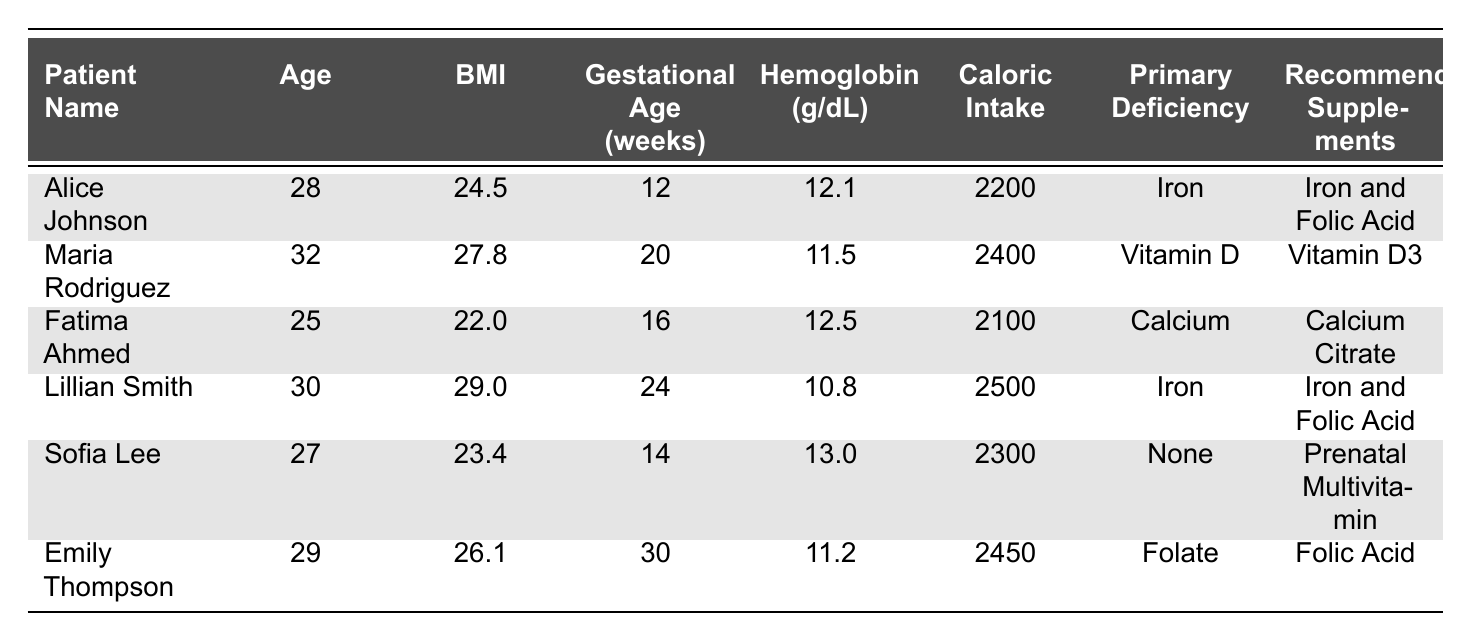What is the BMI of Alice Johnson? The BMI of Alice Johnson is listed directly in the table under her data. It shows a value of 24.5.
Answer: 24.5 Who has the lowest hemoglobin level? By reviewing the hemoglobin levels of all patients in the table, Lillian Smith has the lowest level of 10.8 g/dL.
Answer: Lillian Smith What is the total caloric intake of Maria Rodriguez? The table displays the total caloric intake for Maria Rodriguez, which is 2400 calories.
Answer: 2400 What age range do these patients fall under? The patients' ages range from 25 (Fatima Ahmed) to 32 (Maria Rodriguez), so the range is 25 to 32 years old.
Answer: 25 to 32 years old What percentage of patients has an iron deficiency? There are 6 patients in total, with 2 patients (Alice Johnson and Lillian Smith) having an iron deficiency. The percentage is (2/6) * 100 = 33.33%.
Answer: 33.33% Is there any patient with a primary nutrient deficiency of "None"? The table lists Sofia Lee, who has a primary nutrient deficiency of "None," confirming that there is such a patient.
Answer: Yes What is the average caloric intake of the patients? To find the average caloric intake, sum the caloric intakes (2200 + 2400 + 2100 + 2500 + 2300 + 2450 = 14200) and divide by the number of patients (14200/6 = 2366.67).
Answer: 2366.67 Which patient recommended Folic Acid as a supplement? The table indicates that Emily Thompson is recommended to take Folic Acid as a supplement.
Answer: Emily Thompson How many weeks of gestation does Fatima Ahmed have? The gestational age for Fatima Ahmed is listed in the table as 16 weeks.
Answer: 16 weeks What is the difference between the highest and lowest BMI recorded? The highest BMI is 29.0 (Lillian Smith) and the lowest is 22.0 (Fatima Ahmed). The difference is 29.0 - 22.0 = 7.0.
Answer: 7.0 